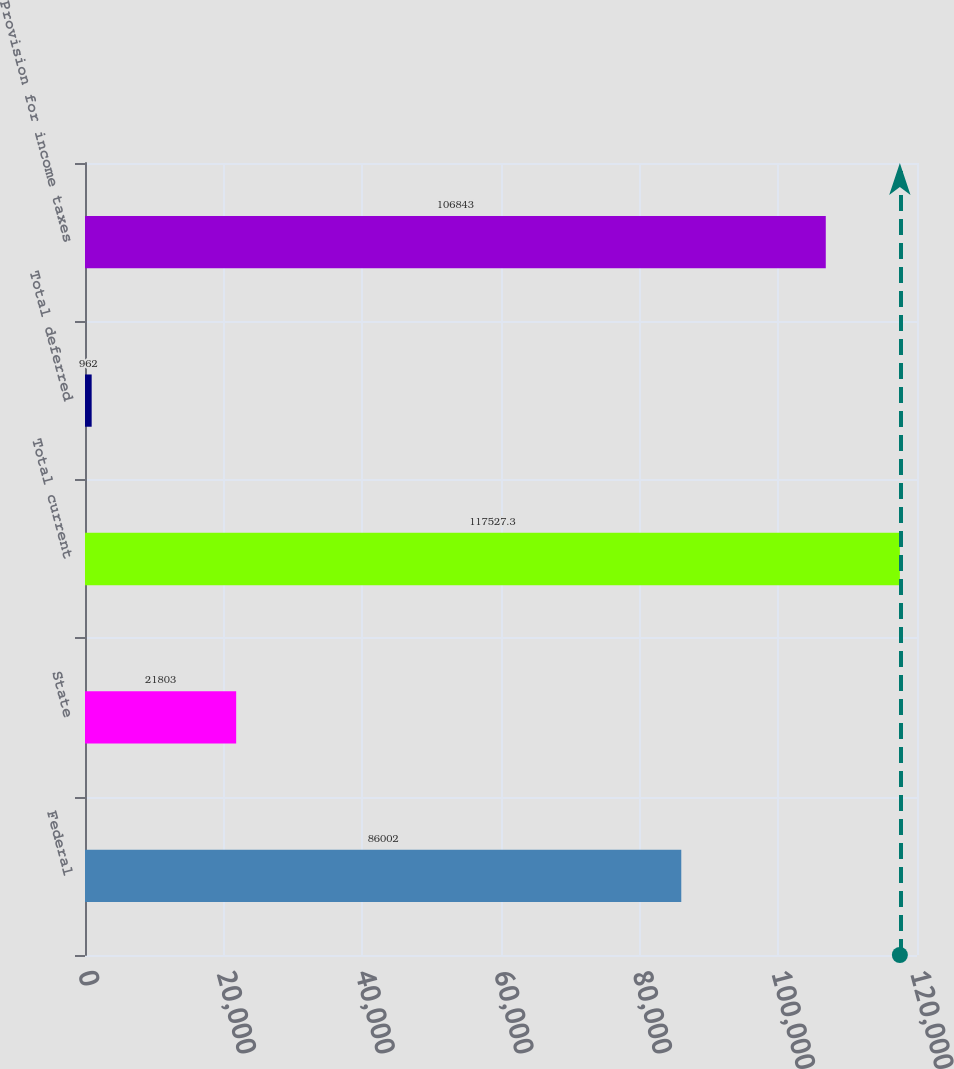Convert chart. <chart><loc_0><loc_0><loc_500><loc_500><bar_chart><fcel>Federal<fcel>State<fcel>Total current<fcel>Total deferred<fcel>Provision for income taxes<nl><fcel>86002<fcel>21803<fcel>117527<fcel>962<fcel>106843<nl></chart> 